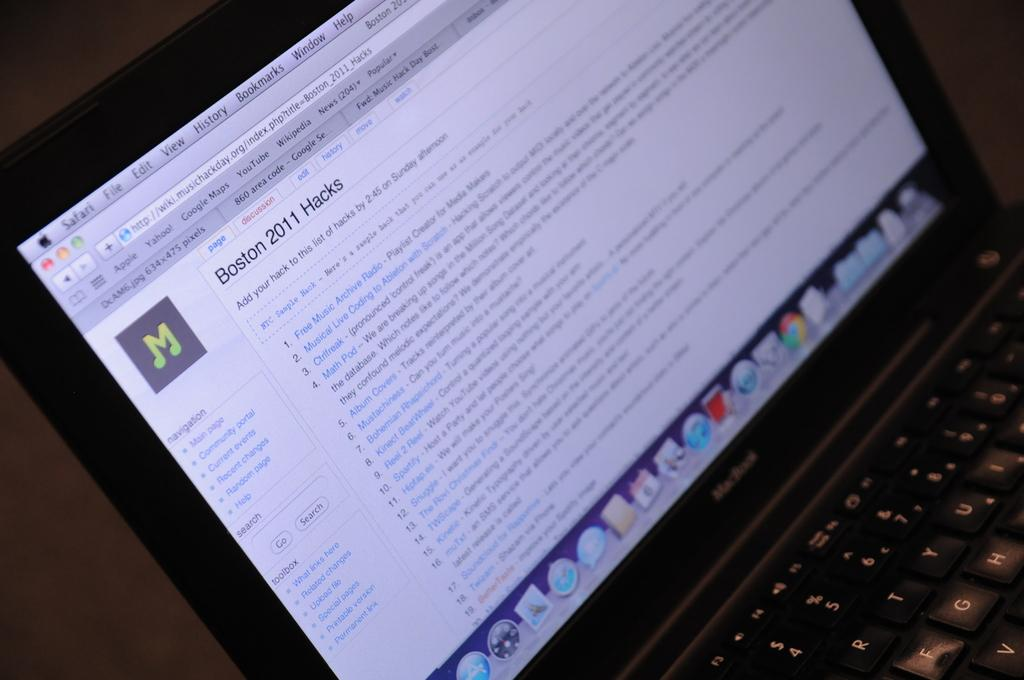What electronic device is visible in the image? There is a laptop in the image. What are the small, raised buttons on the laptop called? The small, raised buttons on the laptop are called keys. What can be seen on the laptop screen? The laptop screen displays icons, files, and words. How many ducks are sitting on the elbow of the person using the laptop in the image? There are no ducks or elbows visible in the image; it only shows a laptop with a screen displaying various items. 